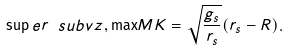<formula> <loc_0><loc_0><loc_500><loc_500>\sup e r { \ s u b { v } { z , \max } } { M K } = \sqrt { \frac { g _ { s } } { r _ { s } } } ( r _ { s } - R ) .</formula> 